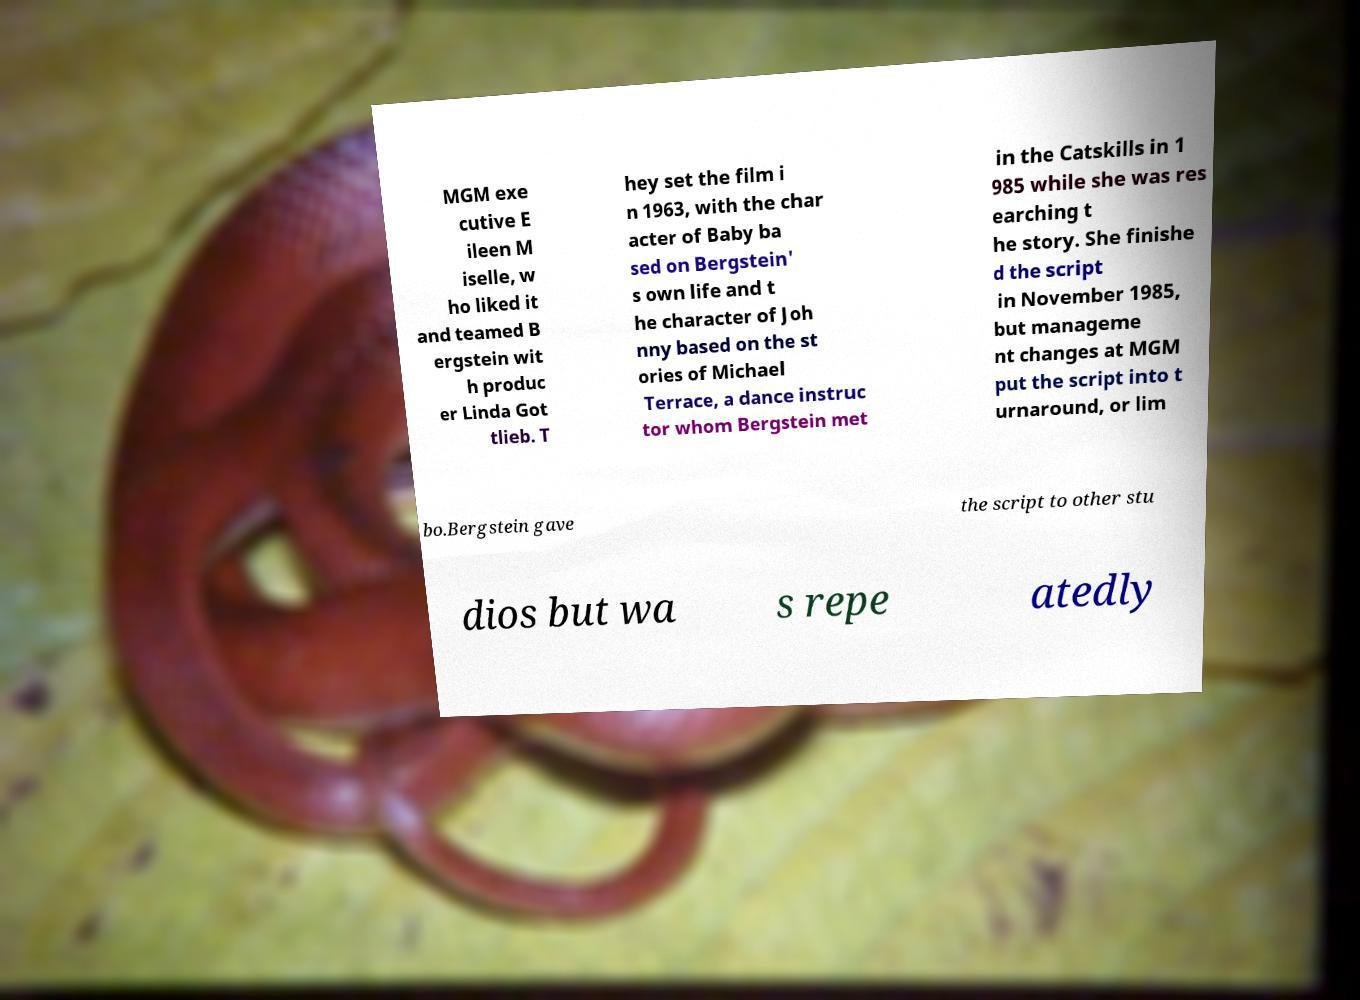Could you assist in decoding the text presented in this image and type it out clearly? MGM exe cutive E ileen M iselle, w ho liked it and teamed B ergstein wit h produc er Linda Got tlieb. T hey set the film i n 1963, with the char acter of Baby ba sed on Bergstein' s own life and t he character of Joh nny based on the st ories of Michael Terrace, a dance instruc tor whom Bergstein met in the Catskills in 1 985 while she was res earching t he story. She finishe d the script in November 1985, but manageme nt changes at MGM put the script into t urnaround, or lim bo.Bergstein gave the script to other stu dios but wa s repe atedly 